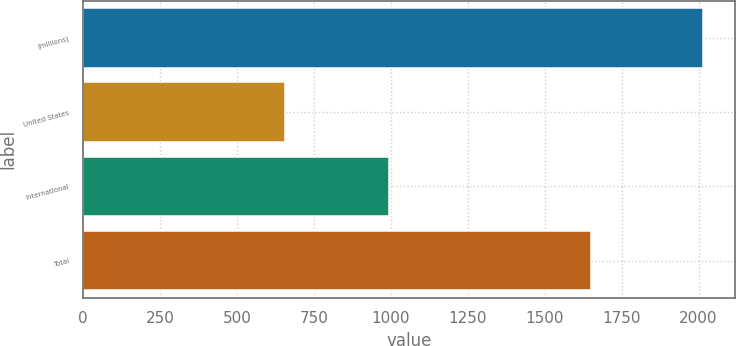Convert chart. <chart><loc_0><loc_0><loc_500><loc_500><bar_chart><fcel>(millions)<fcel>United States<fcel>International<fcel>Total<nl><fcel>2016<fcel>656.1<fcel>994.3<fcel>1650.4<nl></chart> 